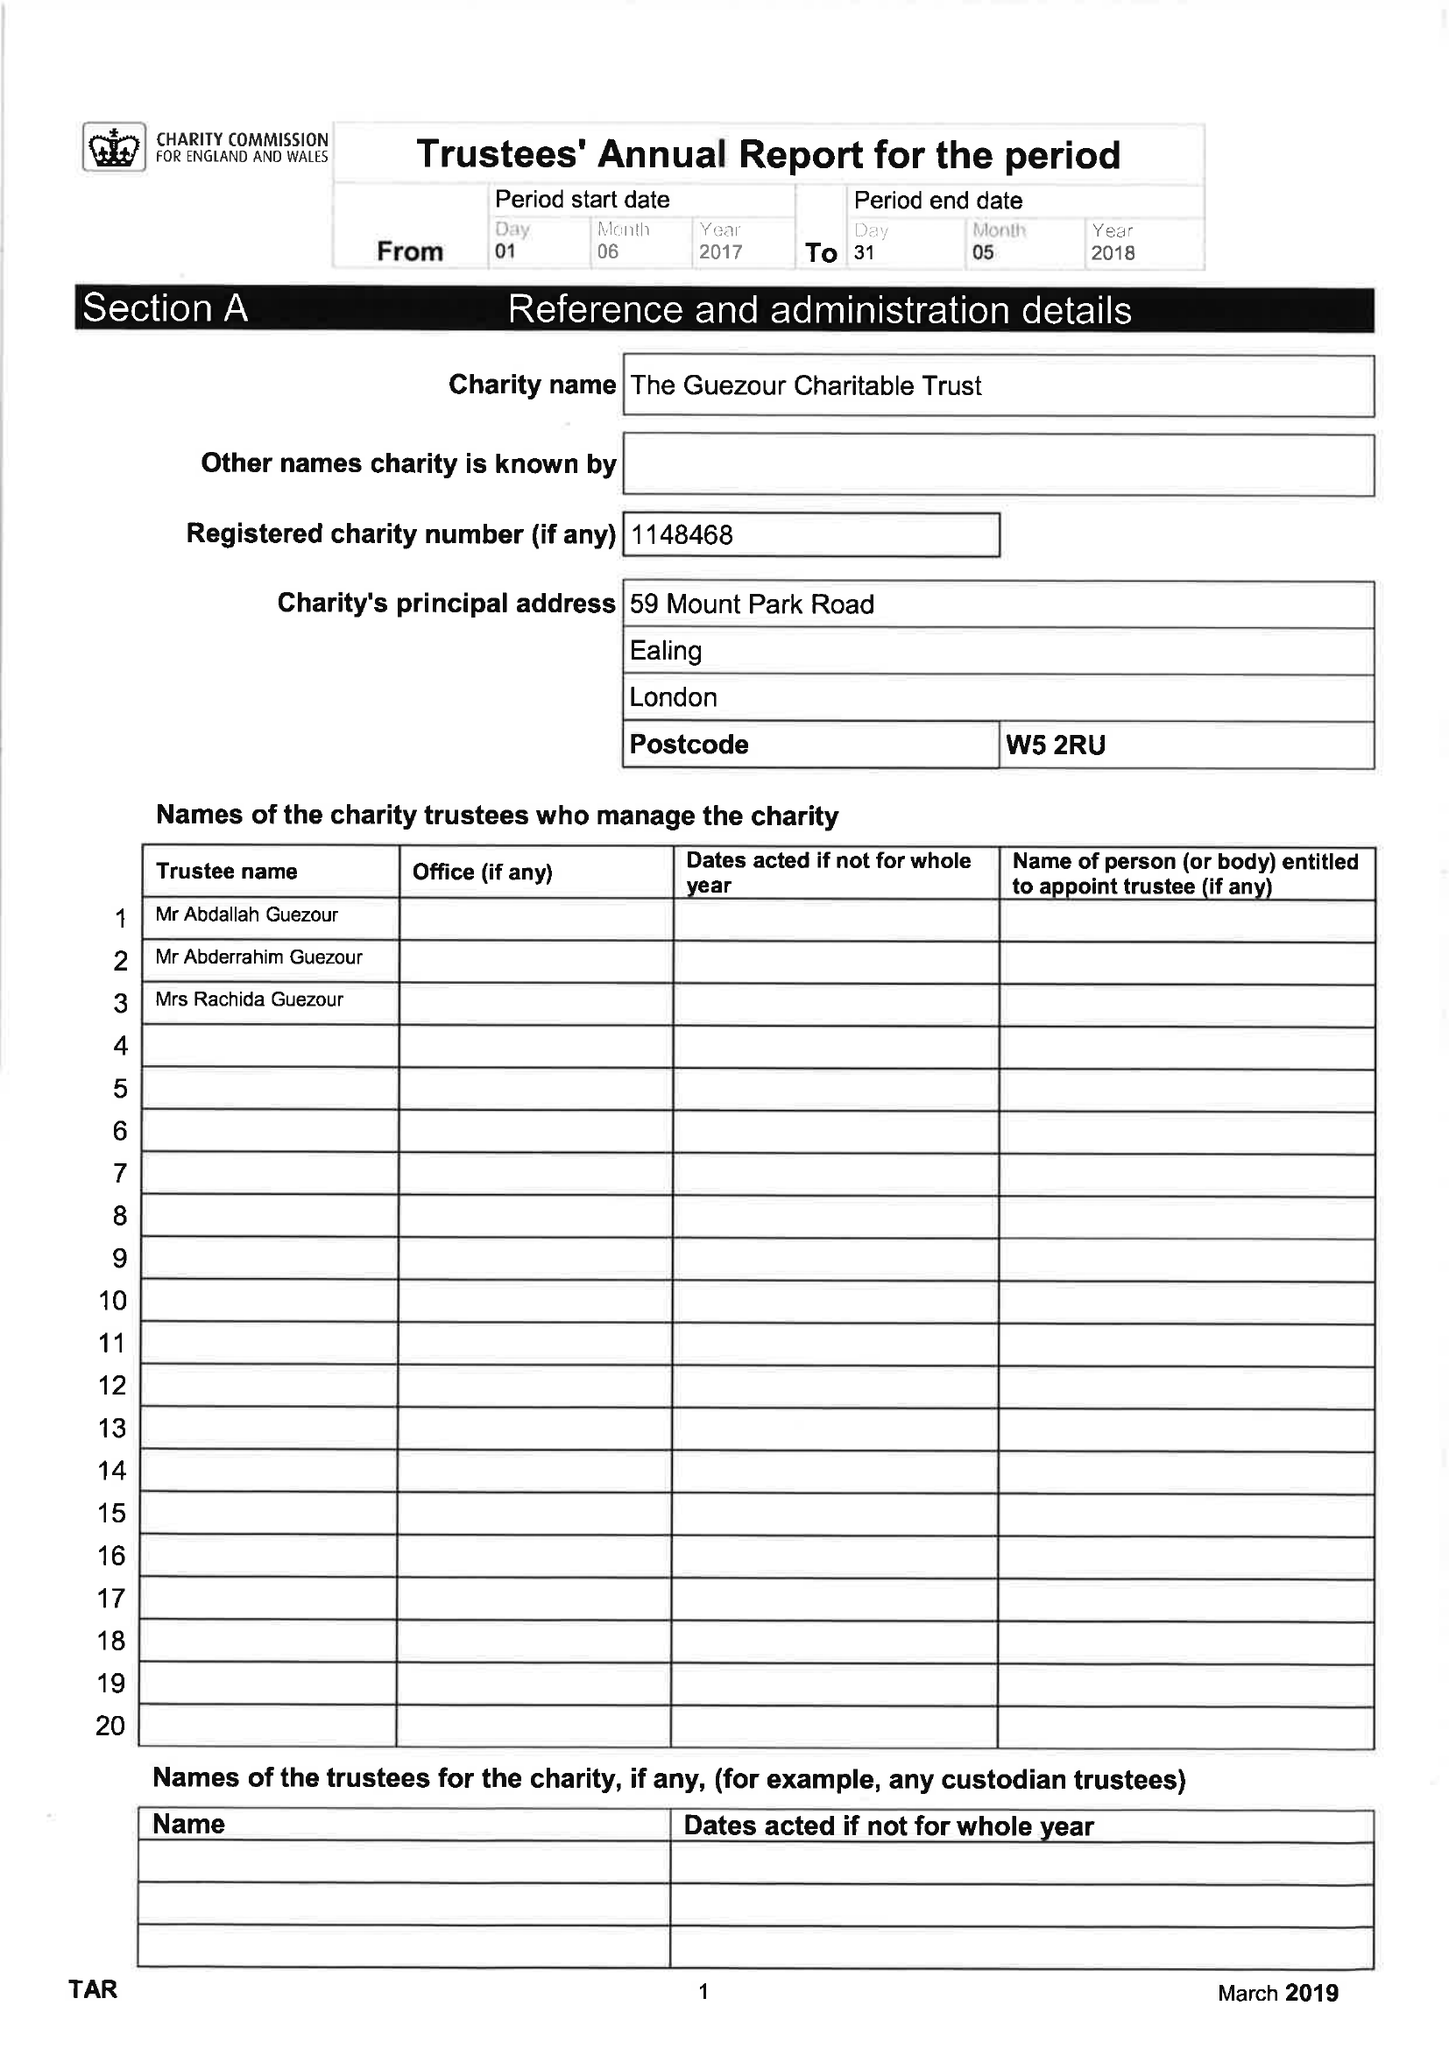What is the value for the address__post_town?
Answer the question using a single word or phrase. LONDON 